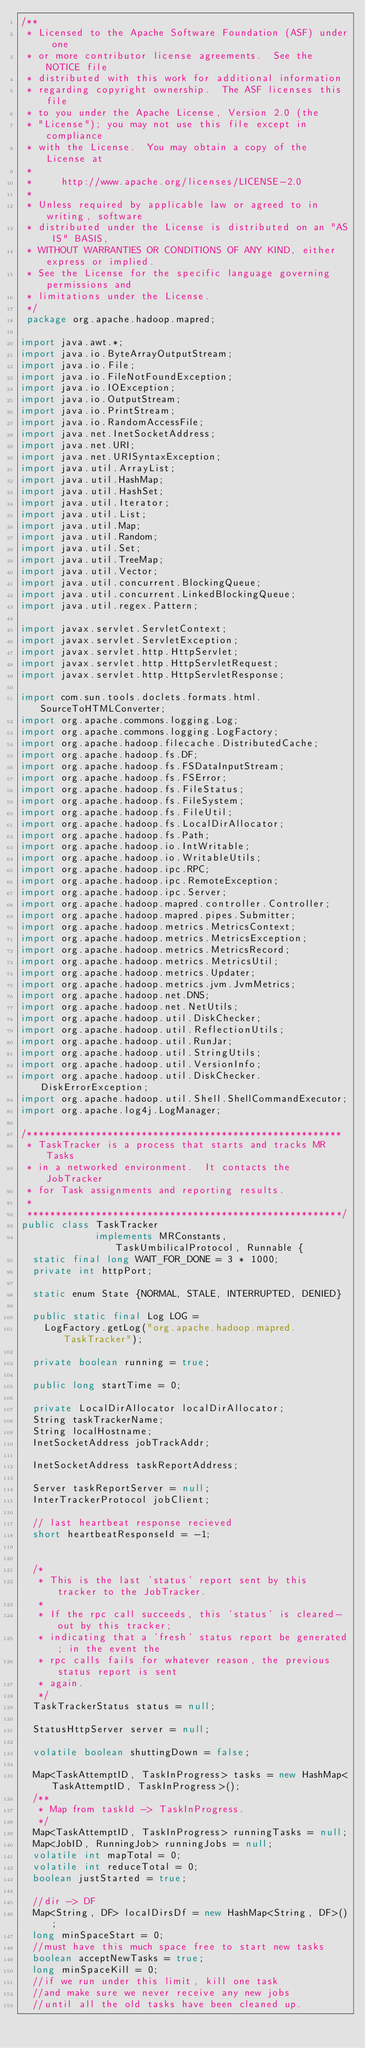<code> <loc_0><loc_0><loc_500><loc_500><_Java_>/**
 * Licensed to the Apache Software Foundation (ASF) under one
 * or more contributor license agreements.  See the NOTICE file
 * distributed with this work for additional information
 * regarding copyright ownership.  The ASF licenses this file
 * to you under the Apache License, Version 2.0 (the
 * "License"); you may not use this file except in compliance
 * with the License.  You may obtain a copy of the License at
 *
 *     http://www.apache.org/licenses/LICENSE-2.0
 *
 * Unless required by applicable law or agreed to in writing, software
 * distributed under the License is distributed on an "AS IS" BASIS,
 * WITHOUT WARRANTIES OR CONDITIONS OF ANY KIND, either express or implied.
 * See the License for the specific language governing permissions and
 * limitations under the License.
 */
 package org.apache.hadoop.mapred;

import java.awt.*;
import java.io.ByteArrayOutputStream;
import java.io.File;
import java.io.FileNotFoundException;
import java.io.IOException;
import java.io.OutputStream;
import java.io.PrintStream;
import java.io.RandomAccessFile;
import java.net.InetSocketAddress;
import java.net.URI;
import java.net.URISyntaxException;
import java.util.ArrayList;
import java.util.HashMap;
import java.util.HashSet;
import java.util.Iterator;
import java.util.List;
import java.util.Map;
import java.util.Random;
import java.util.Set;
import java.util.TreeMap;
import java.util.Vector;
import java.util.concurrent.BlockingQueue;
import java.util.concurrent.LinkedBlockingQueue;
import java.util.regex.Pattern;

import javax.servlet.ServletContext;
import javax.servlet.ServletException;
import javax.servlet.http.HttpServlet;
import javax.servlet.http.HttpServletRequest;
import javax.servlet.http.HttpServletResponse;

import com.sun.tools.doclets.formats.html.SourceToHTMLConverter;
import org.apache.commons.logging.Log;
import org.apache.commons.logging.LogFactory;
import org.apache.hadoop.filecache.DistributedCache;
import org.apache.hadoop.fs.DF;
import org.apache.hadoop.fs.FSDataInputStream;
import org.apache.hadoop.fs.FSError;
import org.apache.hadoop.fs.FileStatus;
import org.apache.hadoop.fs.FileSystem;
import org.apache.hadoop.fs.FileUtil;
import org.apache.hadoop.fs.LocalDirAllocator;
import org.apache.hadoop.fs.Path;
import org.apache.hadoop.io.IntWritable;
import org.apache.hadoop.io.WritableUtils;
import org.apache.hadoop.ipc.RPC;
import org.apache.hadoop.ipc.RemoteException;
import org.apache.hadoop.ipc.Server;
import org.apache.hadoop.mapred.controller.Controller;
import org.apache.hadoop.mapred.pipes.Submitter;
import org.apache.hadoop.metrics.MetricsContext;
import org.apache.hadoop.metrics.MetricsException;
import org.apache.hadoop.metrics.MetricsRecord;
import org.apache.hadoop.metrics.MetricsUtil;
import org.apache.hadoop.metrics.Updater;
import org.apache.hadoop.metrics.jvm.JvmMetrics;
import org.apache.hadoop.net.DNS;
import org.apache.hadoop.net.NetUtils;
import org.apache.hadoop.util.DiskChecker;
import org.apache.hadoop.util.ReflectionUtils;
import org.apache.hadoop.util.RunJar;
import org.apache.hadoop.util.StringUtils;
import org.apache.hadoop.util.VersionInfo;
import org.apache.hadoop.util.DiskChecker.DiskErrorException;
import org.apache.hadoop.util.Shell.ShellCommandExecutor;
import org.apache.log4j.LogManager;

/*******************************************************
 * TaskTracker is a process that starts and tracks MR Tasks
 * in a networked environment.  It contacts the JobTracker
 * for Task assignments and reporting results.
 *
 *******************************************************/
public class TaskTracker 
             implements MRConstants, TaskUmbilicalProtocol, Runnable {
  static final long WAIT_FOR_DONE = 3 * 1000;
  private int httpPort;

  static enum State {NORMAL, STALE, INTERRUPTED, DENIED}

  public static final Log LOG =
    LogFactory.getLog("org.apache.hadoop.mapred.TaskTracker");

  private boolean running = true;

  public long startTime = 0;

  private LocalDirAllocator localDirAllocator;
  String taskTrackerName;
  String localHostname;
  InetSocketAddress jobTrackAddr;
    
  InetSocketAddress taskReportAddress;

  Server taskReportServer = null;
  InterTrackerProtocol jobClient;
    
  // last heartbeat response recieved
  short heartbeatResponseId = -1;


  /*
   * This is the last 'status' report sent by this tracker to the JobTracker.
   * 
   * If the rpc call succeeds, this 'status' is cleared-out by this tracker;
   * indicating that a 'fresh' status report be generated; in the event the
   * rpc calls fails for whatever reason, the previous status report is sent
   * again.
   */
  TaskTrackerStatus status = null;
    
  StatusHttpServer server = null;
    
  volatile boolean shuttingDown = false;
    
  Map<TaskAttemptID, TaskInProgress> tasks = new HashMap<TaskAttemptID, TaskInProgress>();
  /**
   * Map from taskId -> TaskInProgress.
   */
  Map<TaskAttemptID, TaskInProgress> runningTasks = null;
  Map<JobID, RunningJob> runningJobs = null;
  volatile int mapTotal = 0;
  volatile int reduceTotal = 0;
  boolean justStarted = true;
    
  //dir -> DF
  Map<String, DF> localDirsDf = new HashMap<String, DF>();
  long minSpaceStart = 0;
  //must have this much space free to start new tasks
  boolean acceptNewTasks = true;
  long minSpaceKill = 0;
  //if we run under this limit, kill one task
  //and make sure we never receive any new jobs
  //until all the old tasks have been cleaned up.</code> 